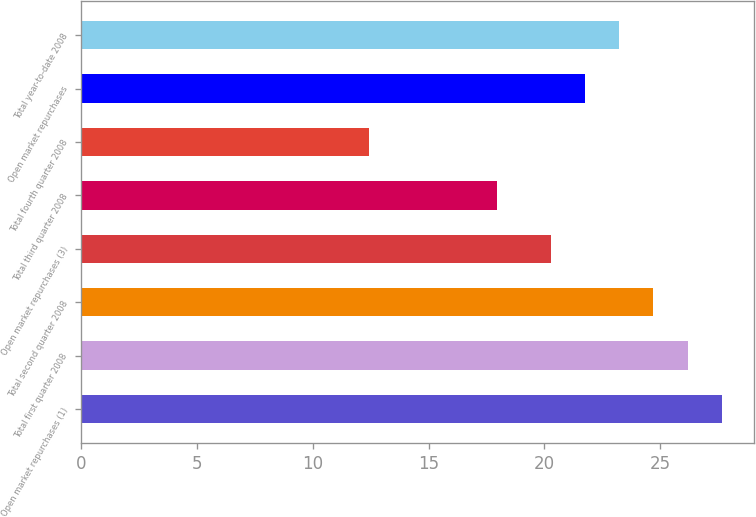Convert chart. <chart><loc_0><loc_0><loc_500><loc_500><bar_chart><fcel>Open market repurchases (1)<fcel>Total first quarter 2008<fcel>Total second quarter 2008<fcel>Open market repurchases (3)<fcel>Total third quarter 2008<fcel>Total fourth quarter 2008<fcel>Open market repurchases<fcel>Total year-to-date 2008<nl><fcel>27.67<fcel>26.19<fcel>24.71<fcel>20.27<fcel>17.96<fcel>12.42<fcel>21.75<fcel>23.23<nl></chart> 